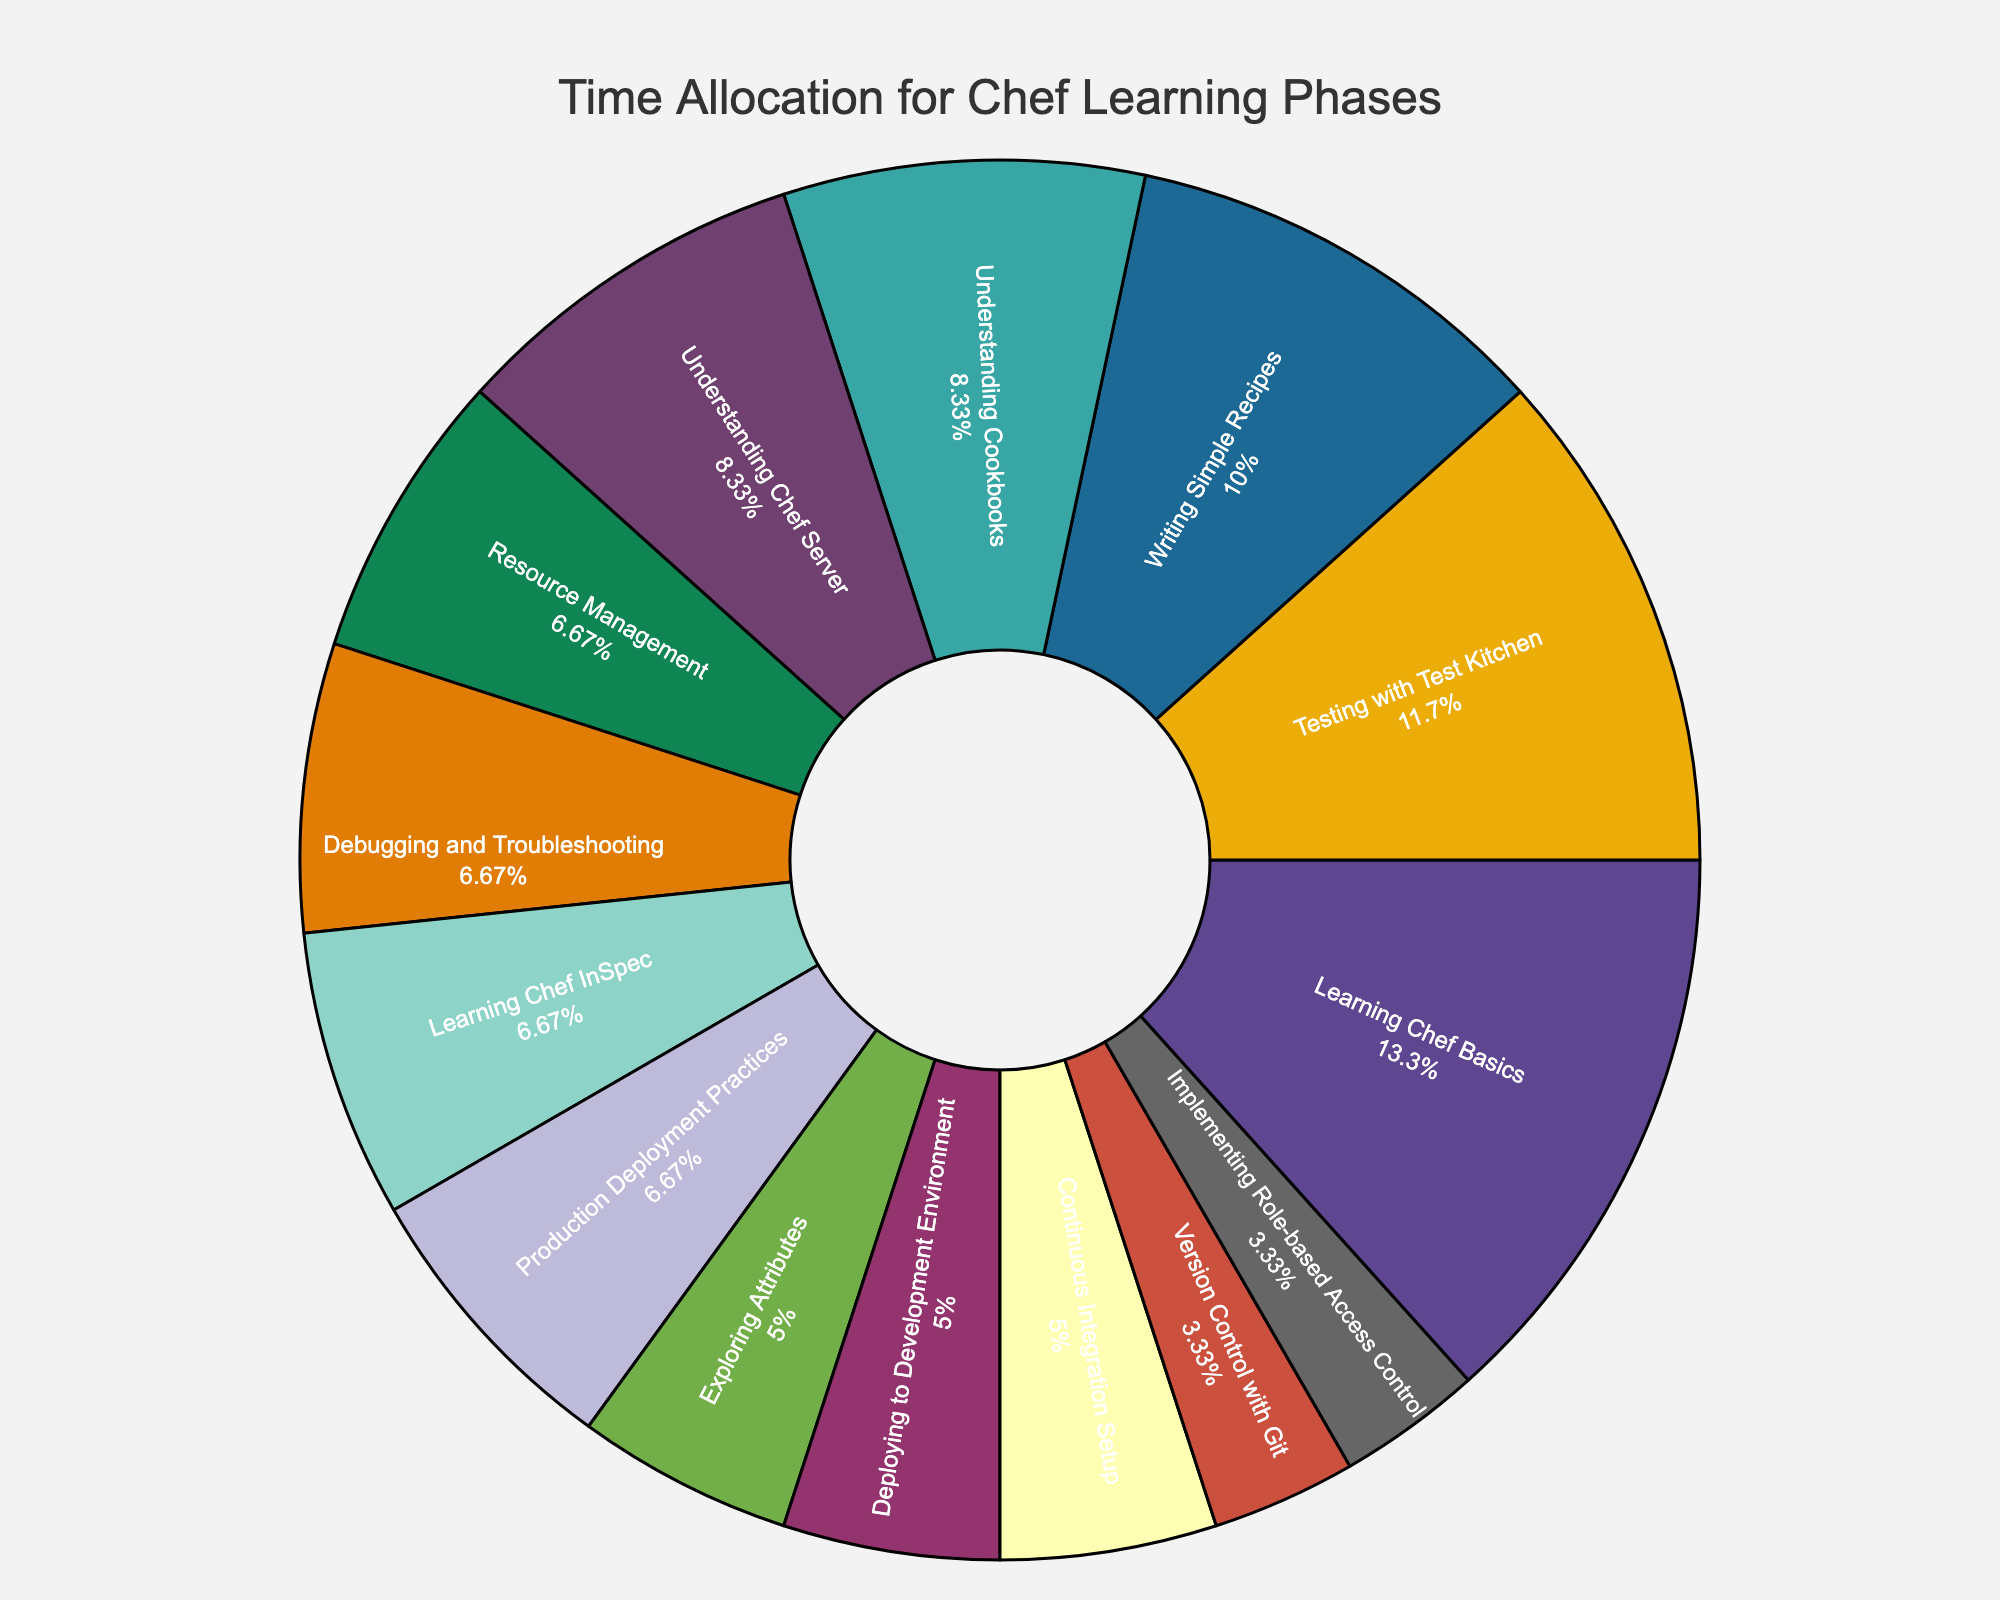What's the percentage of time spent on Learning Chef Basics? Look at the pie chart segment labeled "Learning Chef Basics" and find the percentage displayed next to it.
Answer: 17.4% Which phase is allocated more time: Debugging and Troubleshooting or Continuous Integration Setup? Compare the pie chart segments for "Debugging and Troubleshooting" and "Continuous Integration Setup" by looking at their respective percentages.
Answer: Debugging and Troubleshooting What is the total time spent on Testing with Test Kitchen and Writing Simple Recipes combined? Add the hours allocated to "Testing with Test Kitchen" (35) and "Writing Simple Recipes" (30): 35 + 30 = 65 hours.
Answer: 65 hours What visual element indicates the phase with the lowest time allocation? The smallest segment in the pie chart represents the phase with the lowest time allocation. Identify the smallest segment.
Answer: Version Control with Git How much more time is allocated to Learning Chef Basics compared to Deploying to Development Environment? Subtract the hours for "Deploying to Development Environment" (15) from the hours for "Learning Chef Basics" (40): 40 - 15 = 25 hours.
Answer: 25 hours What is the combined percentage of time spent on Understanding Cookbooks and Understanding Chef Server? Find the percentages for "Understanding Cookbooks" and "Understanding Chef Server" and add them together: 10.9% + 10.9% = 21.8%.
Answer: 21.8% Which phase has a larger time allocation: Resource Management or Learning Chef InSpec? Compare the pie chart segments for "Resource Management" and "Learning Chef InSpec" by examining the percentages.
Answer: Resource Management What's the average time allocation for the three phases: Understanding Cookbooks, Learning Chef InSpec, and Production Deployment Practices? Calculate the average by summing the hours for these phases (25 + 20 + 20) and dividing by 3: (25 + 20 + 20) / 3 = 21.7 hours.
Answer: 21.7 hours Which phase occupies the largest portion of the pie chart? Identify the pie chart segment with the largest percentage displayed next to it; this denotes the phase with the highest time allocation.
Answer: Learning Chef Basics 